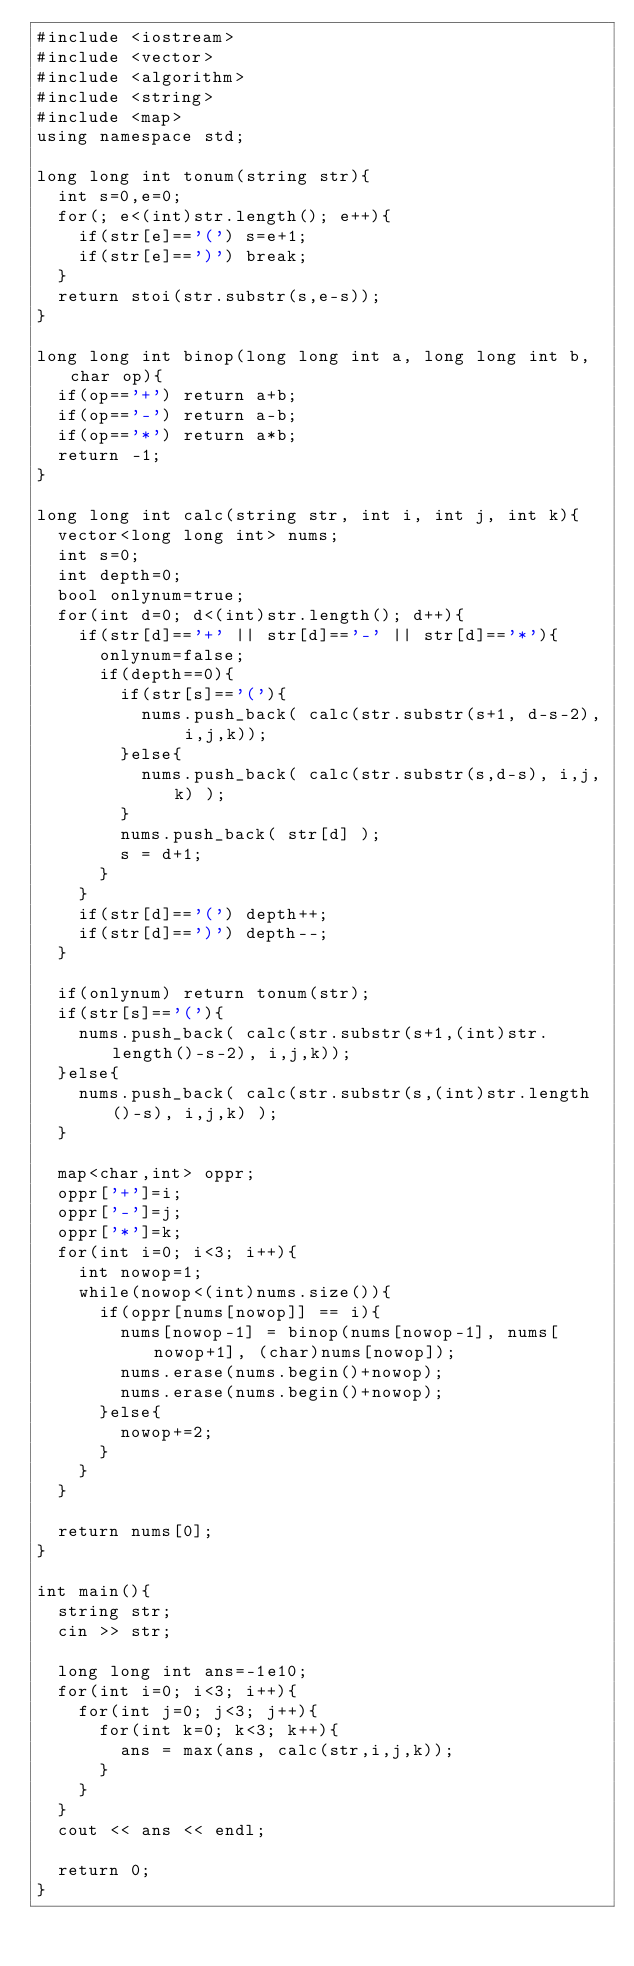Convert code to text. <code><loc_0><loc_0><loc_500><loc_500><_C++_>#include <iostream>
#include <vector>
#include <algorithm>
#include <string>
#include <map>
using namespace std;

long long int tonum(string str){
  int s=0,e=0;
  for(; e<(int)str.length(); e++){
    if(str[e]=='(') s=e+1;
    if(str[e]==')') break;
  }
  return stoi(str.substr(s,e-s));
}

long long int binop(long long int a, long long int b, char op){
  if(op=='+') return a+b;
  if(op=='-') return a-b;
  if(op=='*') return a*b;
  return -1;
}

long long int calc(string str, int i, int j, int k){
  vector<long long int> nums;
  int s=0;
  int depth=0;
  bool onlynum=true;
  for(int d=0; d<(int)str.length(); d++){
    if(str[d]=='+' || str[d]=='-' || str[d]=='*'){
      onlynum=false;
      if(depth==0){
        if(str[s]=='('){
          nums.push_back( calc(str.substr(s+1, d-s-2), i,j,k));
        }else{
          nums.push_back( calc(str.substr(s,d-s), i,j,k) );
        }
        nums.push_back( str[d] );
        s = d+1;
      }
    }
    if(str[d]=='(') depth++;
    if(str[d]==')') depth--;
  }

  if(onlynum) return tonum(str);
  if(str[s]=='('){
    nums.push_back( calc(str.substr(s+1,(int)str.length()-s-2), i,j,k));
  }else{
    nums.push_back( calc(str.substr(s,(int)str.length()-s), i,j,k) );
  }

  map<char,int> oppr;
  oppr['+']=i;
  oppr['-']=j;
  oppr['*']=k;
  for(int i=0; i<3; i++){
    int nowop=1;
    while(nowop<(int)nums.size()){
      if(oppr[nums[nowop]] == i){
        nums[nowop-1] = binop(nums[nowop-1], nums[nowop+1], (char)nums[nowop]);
        nums.erase(nums.begin()+nowop);
        nums.erase(nums.begin()+nowop);
      }else{
        nowop+=2;
      }
    }
  }

  return nums[0];
}

int main(){
  string str;
  cin >> str;

  long long int ans=-1e10;
  for(int i=0; i<3; i++){
    for(int j=0; j<3; j++){
      for(int k=0; k<3; k++){
        ans = max(ans, calc(str,i,j,k));
      }
    }
  }
  cout << ans << endl;

  return 0;
}</code> 